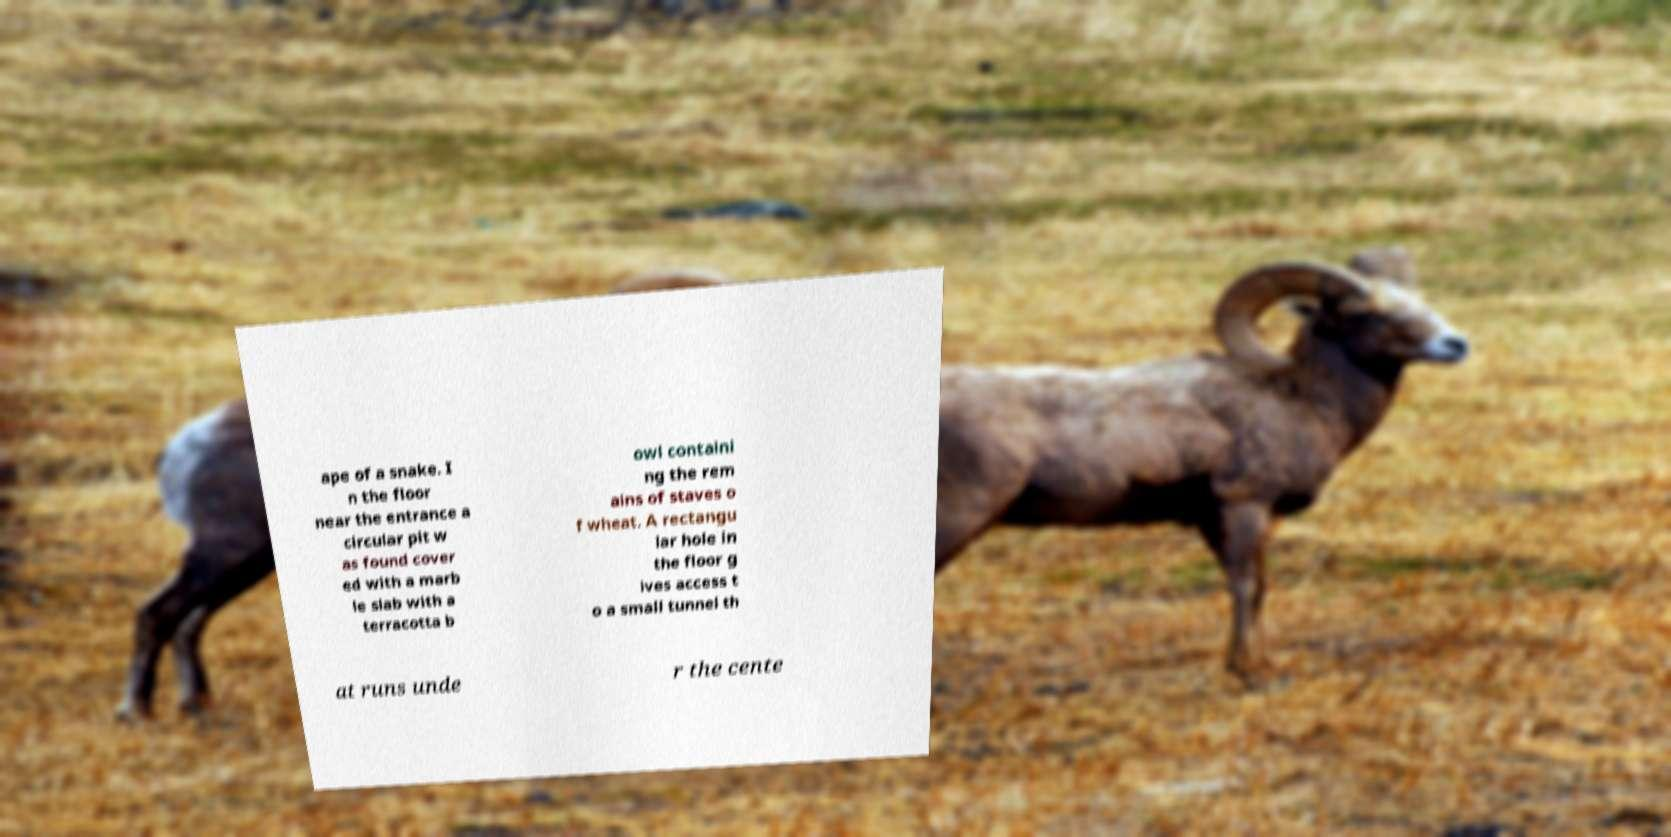Could you assist in decoding the text presented in this image and type it out clearly? ape of a snake. I n the floor near the entrance a circular pit w as found cover ed with a marb le slab with a terracotta b owl containi ng the rem ains of staves o f wheat. A rectangu lar hole in the floor g ives access t o a small tunnel th at runs unde r the cente 